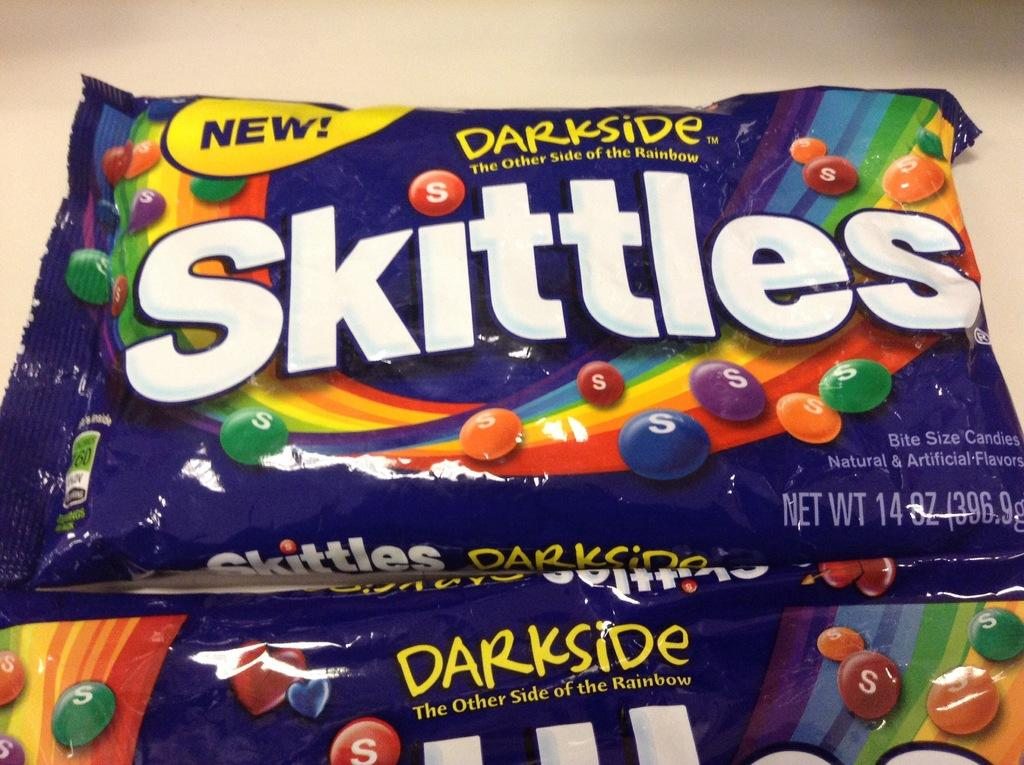What type of food is contained in the packets in the image? The packets contain chocolate. What brand is associated with the chocolate in the image? The word "Skittles" is written on the packets. What type of cave can be seen in the image? There is no cave present in the image; it features packets of chocolate with the word "Skittles" written on them. How does the memory of the chocolate affect the taste in the image? There is no mention of memory or taste in the image, as it only shows packets of chocolate with the word "Skittles" written on them. 